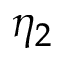Convert formula to latex. <formula><loc_0><loc_0><loc_500><loc_500>\eta _ { 2 }</formula> 